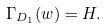<formula> <loc_0><loc_0><loc_500><loc_500>\Gamma _ { D _ { 1 } } ( w ) = H .</formula> 